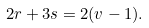Convert formula to latex. <formula><loc_0><loc_0><loc_500><loc_500>2 r + 3 s = 2 ( v - 1 ) .</formula> 